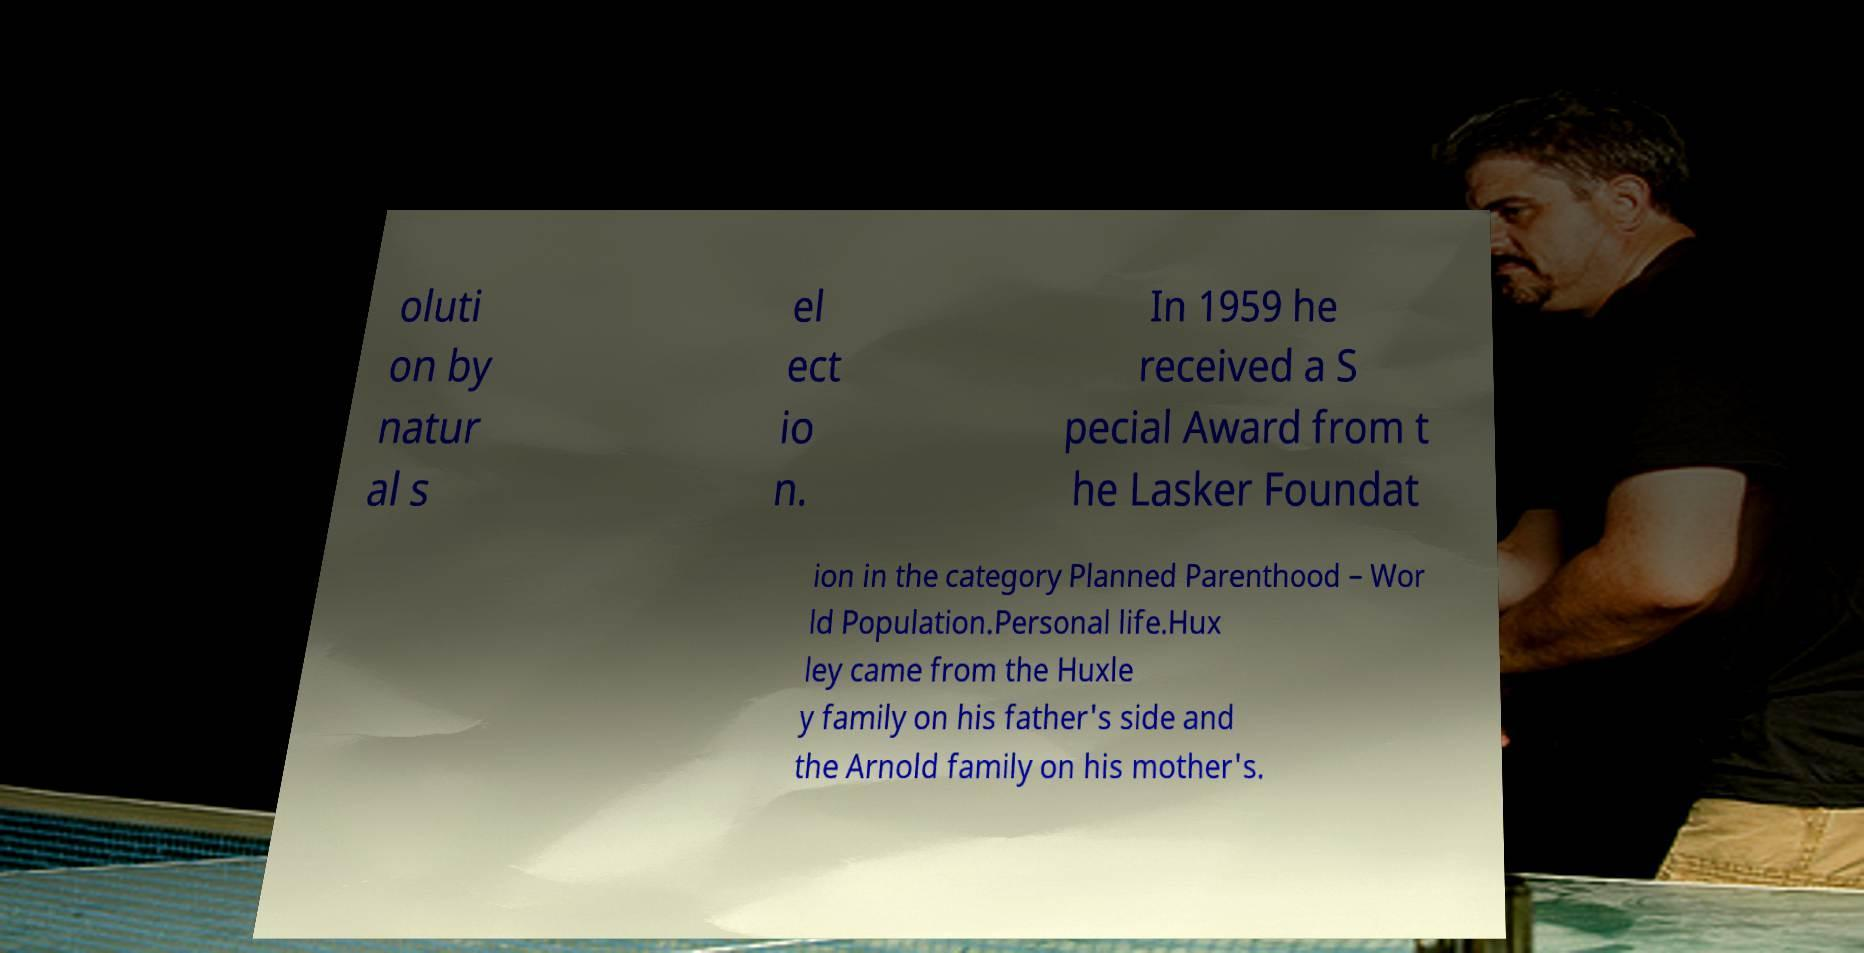Could you extract and type out the text from this image? oluti on by natur al s el ect io n. In 1959 he received a S pecial Award from t he Lasker Foundat ion in the category Planned Parenthood – Wor ld Population.Personal life.Hux ley came from the Huxle y family on his father's side and the Arnold family on his mother's. 